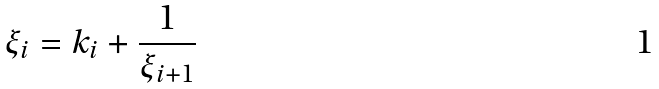Convert formula to latex. <formula><loc_0><loc_0><loc_500><loc_500>\xi _ { i } = k _ { i } + \frac { 1 } { \xi _ { i + 1 } }</formula> 